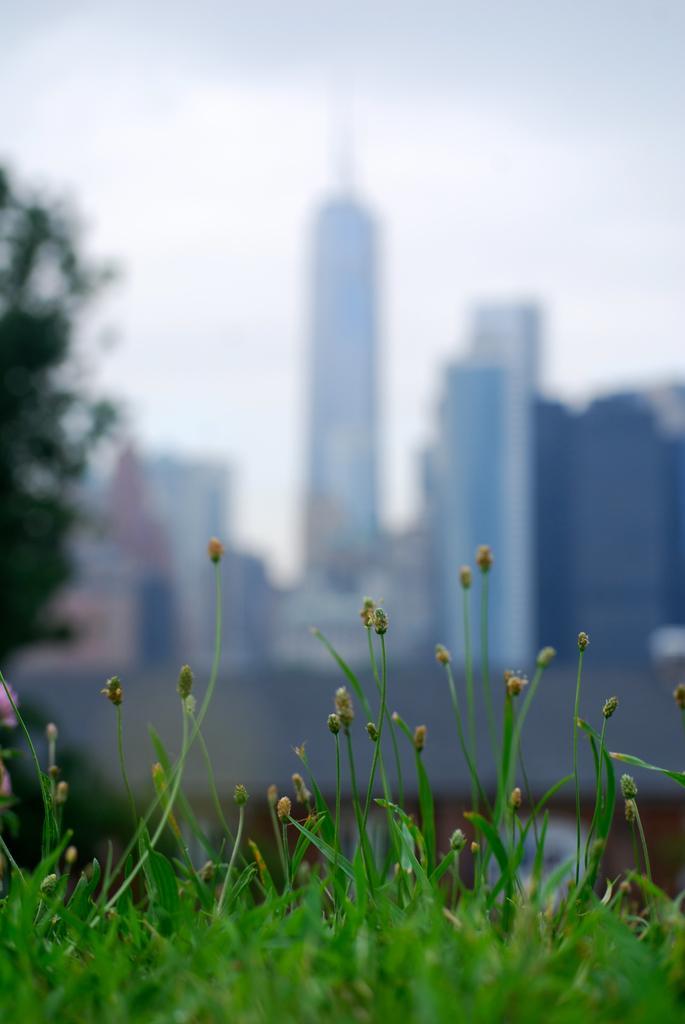Can you describe this image briefly? This image consists of green grass on the ground. To the left, there is a tree. In the background, there are skyscrapers. And the background, there is blurred. 